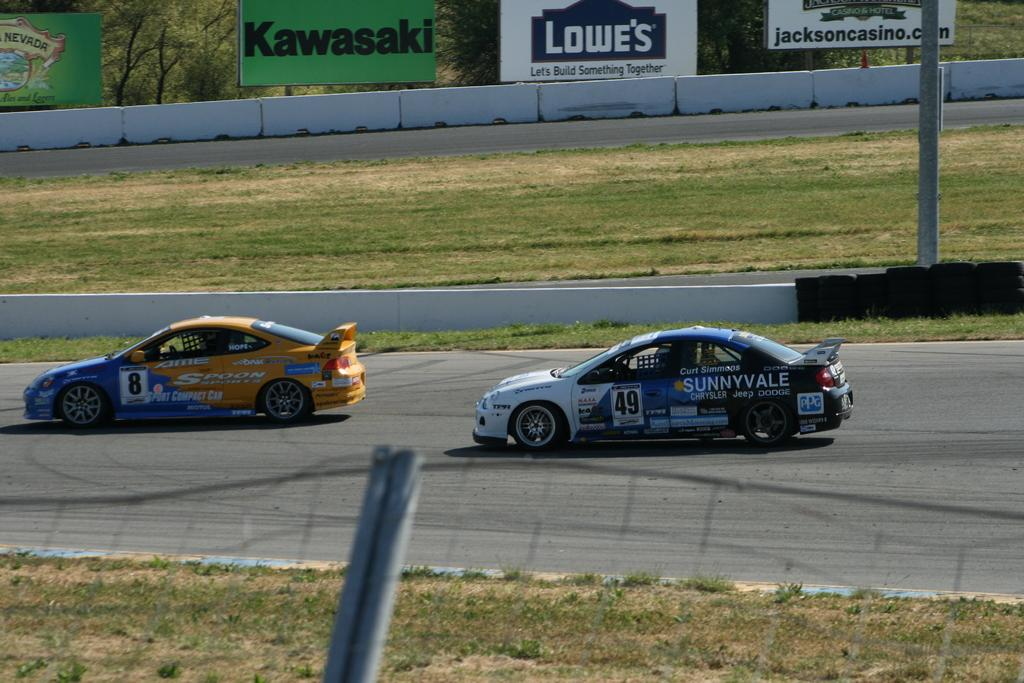What is happening on the road in the image? There are two cars passing on the road. What can be seen on either side of the road? There is grass on either side of the road. What is visible in the background of the image? There are banners and trees in the background of the image. Can you touch the spot where the cars are passing in the image? It is not possible to touch the spot where the cars are passing in the image, as it is a two-dimensional representation. 